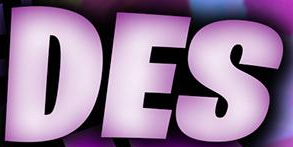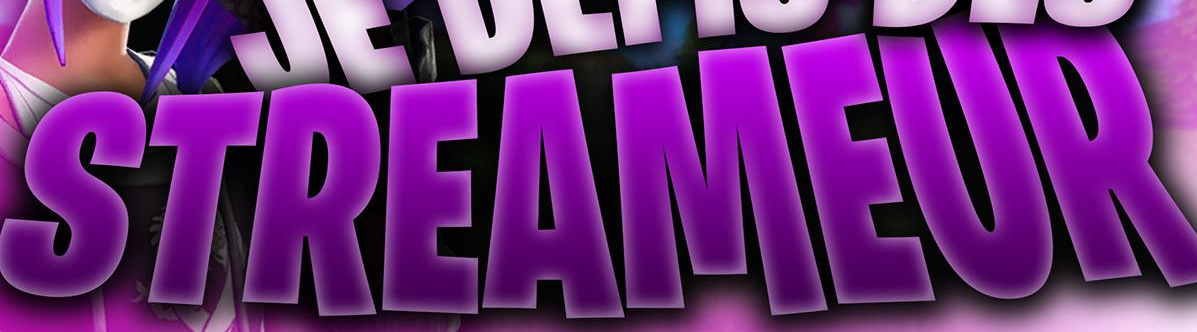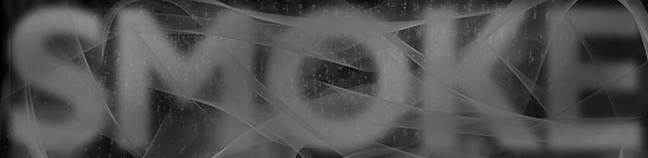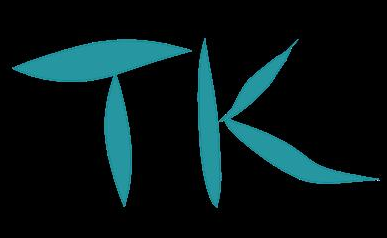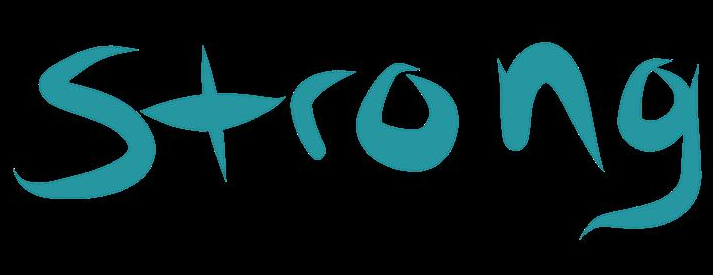Transcribe the words shown in these images in order, separated by a semicolon. DES; STREAMEUR; SMOKE; TK; Strong 